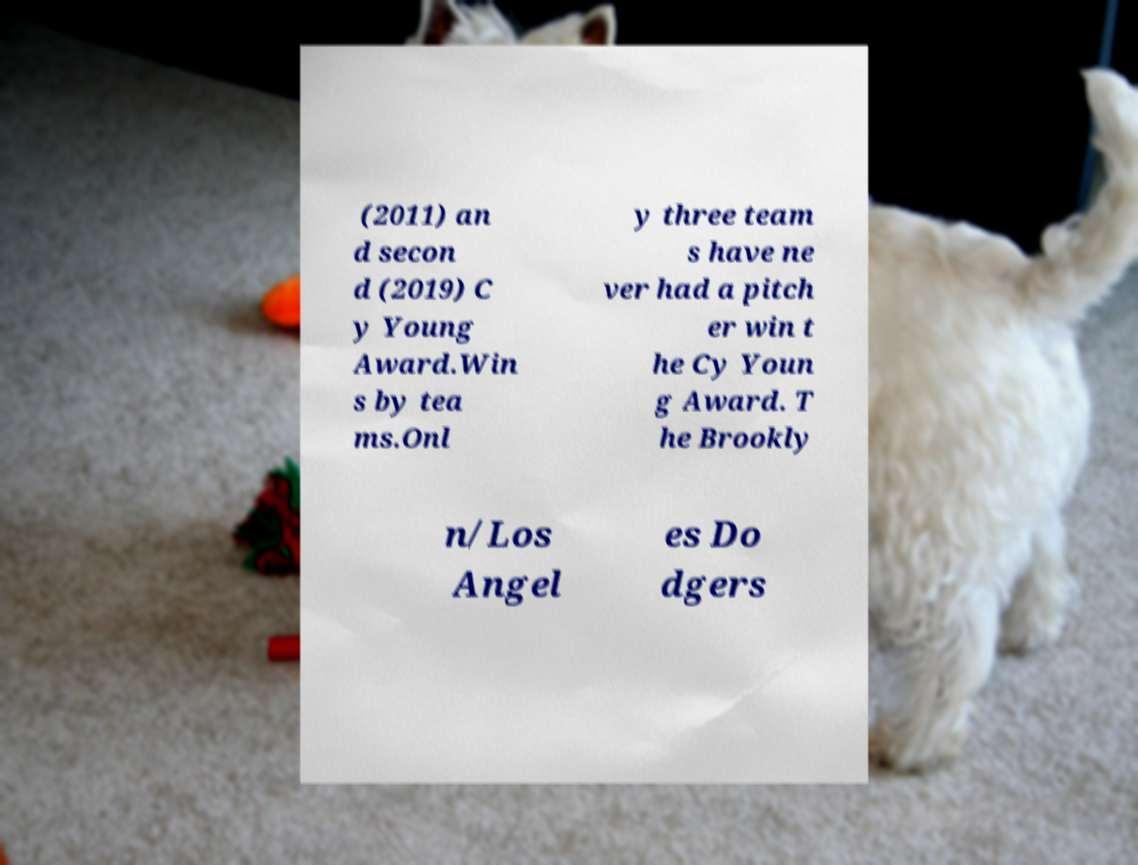There's text embedded in this image that I need extracted. Can you transcribe it verbatim? (2011) an d secon d (2019) C y Young Award.Win s by tea ms.Onl y three team s have ne ver had a pitch er win t he Cy Youn g Award. T he Brookly n/Los Angel es Do dgers 